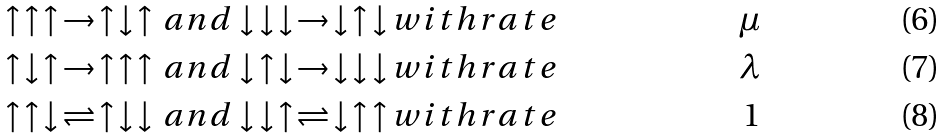<formula> <loc_0><loc_0><loc_500><loc_500>\uparrow \, \uparrow \, \uparrow \, \to \, \uparrow \, \downarrow \, \uparrow \, a n d \downarrow \, \downarrow \, \downarrow \, \to \, \downarrow \, \uparrow \, \downarrow \, & w i t h r a t e & \mu \\ \uparrow \, \downarrow \, \uparrow \, \to \, \uparrow \, \uparrow \, \uparrow \, a n d \downarrow \, \uparrow \, \downarrow \, \to \, \downarrow \, \downarrow \, \downarrow \, & w i t h r a t e & \lambda \\ \uparrow \, \uparrow \, \downarrow \, \rightleftharpoons \, \uparrow \, \downarrow \, \downarrow \, a n d \downarrow \, \downarrow \, \uparrow \, \rightleftharpoons \, \downarrow \, \uparrow \, \uparrow \, & w i t h r a t e & 1</formula> 